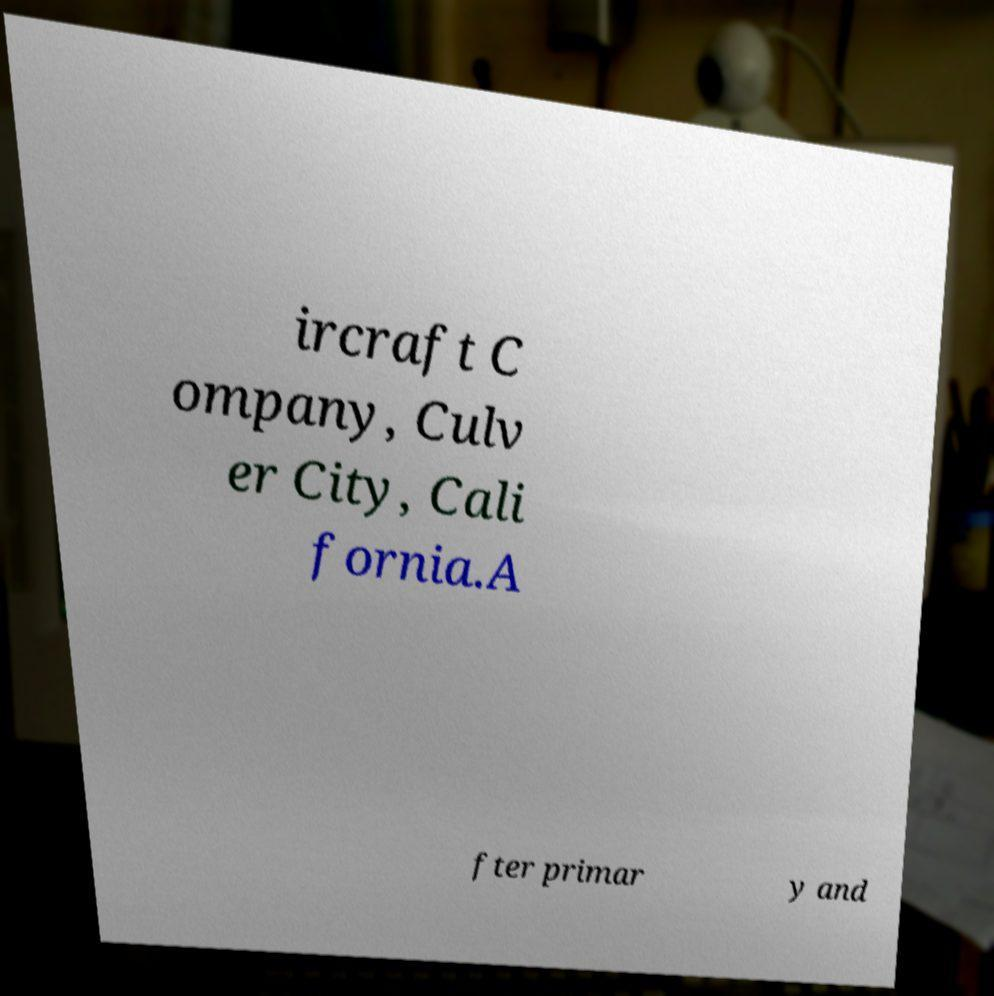What messages or text are displayed in this image? I need them in a readable, typed format. ircraft C ompany, Culv er City, Cali fornia.A fter primar y and 